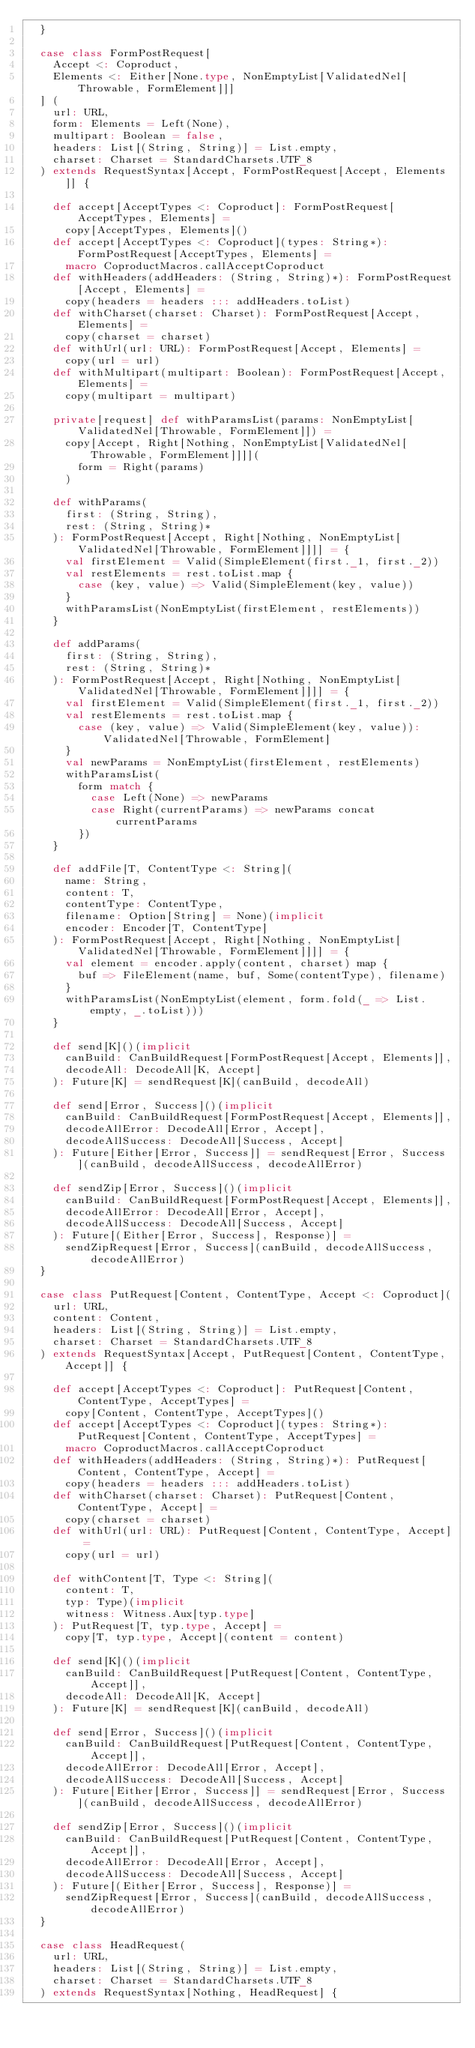Convert code to text. <code><loc_0><loc_0><loc_500><loc_500><_Scala_>  }

  case class FormPostRequest[
    Accept <: Coproduct,
    Elements <: Either[None.type, NonEmptyList[ValidatedNel[Throwable, FormElement]]]
  ] (
    url: URL,
    form: Elements = Left(None),
    multipart: Boolean = false,
    headers: List[(String, String)] = List.empty,
    charset: Charset = StandardCharsets.UTF_8
  ) extends RequestSyntax[Accept, FormPostRequest[Accept, Elements]] {

    def accept[AcceptTypes <: Coproduct]: FormPostRequest[AcceptTypes, Elements] =
      copy[AcceptTypes, Elements]()
    def accept[AcceptTypes <: Coproduct](types: String*): FormPostRequest[AcceptTypes, Elements] =
      macro CoproductMacros.callAcceptCoproduct
    def withHeaders(addHeaders: (String, String)*): FormPostRequest[Accept, Elements] =
      copy(headers = headers ::: addHeaders.toList)
    def withCharset(charset: Charset): FormPostRequest[Accept, Elements] =
      copy(charset = charset)
    def withUrl(url: URL): FormPostRequest[Accept, Elements] =
      copy(url = url)
    def withMultipart(multipart: Boolean): FormPostRequest[Accept, Elements] =
      copy(multipart = multipart)

    private[request] def withParamsList(params: NonEmptyList[ValidatedNel[Throwable, FormElement]]) =
      copy[Accept, Right[Nothing, NonEmptyList[ValidatedNel[Throwable, FormElement]]]](
        form = Right(params)
      )

    def withParams(
      first: (String, String),
      rest: (String, String)*
    ): FormPostRequest[Accept, Right[Nothing, NonEmptyList[ValidatedNel[Throwable, FormElement]]]] = {
      val firstElement = Valid(SimpleElement(first._1, first._2))
      val restElements = rest.toList.map {
        case (key, value) => Valid(SimpleElement(key, value))
      }
      withParamsList(NonEmptyList(firstElement, restElements))
    }

    def addParams(
      first: (String, String),
      rest: (String, String)*
    ): FormPostRequest[Accept, Right[Nothing, NonEmptyList[ValidatedNel[Throwable, FormElement]]]] = {
      val firstElement = Valid(SimpleElement(first._1, first._2))
      val restElements = rest.toList.map {
        case (key, value) => Valid(SimpleElement(key, value)): ValidatedNel[Throwable, FormElement]
      }
      val newParams = NonEmptyList(firstElement, restElements)
      withParamsList(
        form match {
          case Left(None) => newParams
          case Right(currentParams) => newParams concat currentParams
        })
    }

    def addFile[T, ContentType <: String](
      name: String,
      content: T,
      contentType: ContentType,
      filename: Option[String] = None)(implicit
      encoder: Encoder[T, ContentType]
    ): FormPostRequest[Accept, Right[Nothing, NonEmptyList[ValidatedNel[Throwable, FormElement]]]] = {
      val element = encoder.apply(content, charset) map {
        buf => FileElement(name, buf, Some(contentType), filename)
      }
      withParamsList(NonEmptyList(element, form.fold(_ => List.empty, _.toList)))
    }

    def send[K]()(implicit
      canBuild: CanBuildRequest[FormPostRequest[Accept, Elements]],
      decodeAll: DecodeAll[K, Accept]
    ): Future[K] = sendRequest[K](canBuild, decodeAll)

    def send[Error, Success]()(implicit
      canBuild: CanBuildRequest[FormPostRequest[Accept, Elements]],
      decodeAllError: DecodeAll[Error, Accept],
      decodeAllSuccess: DecodeAll[Success, Accept]
    ): Future[Either[Error, Success]] = sendRequest[Error, Success](canBuild, decodeAllSuccess, decodeAllError)

    def sendZip[Error, Success]()(implicit
      canBuild: CanBuildRequest[FormPostRequest[Accept, Elements]],
      decodeAllError: DecodeAll[Error, Accept],
      decodeAllSuccess: DecodeAll[Success, Accept]
    ): Future[(Either[Error, Success], Response)] =
      sendZipRequest[Error, Success](canBuild, decodeAllSuccess, decodeAllError)
  }

  case class PutRequest[Content, ContentType, Accept <: Coproduct](
    url: URL,
    content: Content,
    headers: List[(String, String)] = List.empty,
    charset: Charset = StandardCharsets.UTF_8
  ) extends RequestSyntax[Accept, PutRequest[Content, ContentType, Accept]] {

    def accept[AcceptTypes <: Coproduct]: PutRequest[Content, ContentType, AcceptTypes] =
      copy[Content, ContentType, AcceptTypes]()
    def accept[AcceptTypes <: Coproduct](types: String*): PutRequest[Content, ContentType, AcceptTypes] =
      macro CoproductMacros.callAcceptCoproduct
    def withHeaders(addHeaders: (String, String)*): PutRequest[Content, ContentType, Accept] =
      copy(headers = headers ::: addHeaders.toList)
    def withCharset(charset: Charset): PutRequest[Content, ContentType, Accept] =
      copy(charset = charset)
    def withUrl(url: URL): PutRequest[Content, ContentType, Accept] =
      copy(url = url)

    def withContent[T, Type <: String](
      content: T,
      typ: Type)(implicit
      witness: Witness.Aux[typ.type]
    ): PutRequest[T, typ.type, Accept] =
      copy[T, typ.type, Accept](content = content)

    def send[K]()(implicit
      canBuild: CanBuildRequest[PutRequest[Content, ContentType, Accept]],
      decodeAll: DecodeAll[K, Accept]
    ): Future[K] = sendRequest[K](canBuild, decodeAll)

    def send[Error, Success]()(implicit
      canBuild: CanBuildRequest[PutRequest[Content, ContentType, Accept]],
      decodeAllError: DecodeAll[Error, Accept],
      decodeAllSuccess: DecodeAll[Success, Accept]
    ): Future[Either[Error, Success]] = sendRequest[Error, Success](canBuild, decodeAllSuccess, decodeAllError)

    def sendZip[Error, Success]()(implicit
      canBuild: CanBuildRequest[PutRequest[Content, ContentType, Accept]],
      decodeAllError: DecodeAll[Error, Accept],
      decodeAllSuccess: DecodeAll[Success, Accept]
    ): Future[(Either[Error, Success], Response)] =
      sendZipRequest[Error, Success](canBuild, decodeAllSuccess, decodeAllError)
  }

  case class HeadRequest(
    url: URL,
    headers: List[(String, String)] = List.empty,
    charset: Charset = StandardCharsets.UTF_8
  ) extends RequestSyntax[Nothing, HeadRequest] {
</code> 